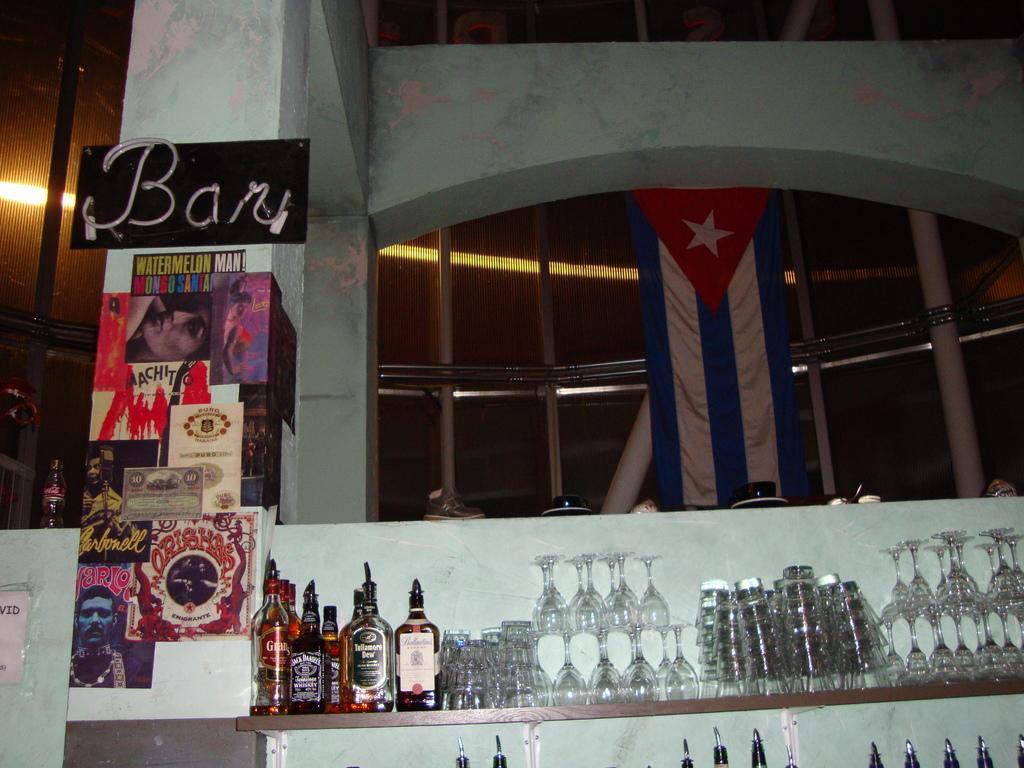Please provide a concise description of this image. In this picture we can see bottles and glasses on the rack. On the left side of the image, there is a pillar with a board and posters attached to it. Behind the bottle, there is a wall. On top of the wall, there are some objects. Behind the wall, there are poles, light, a banner and some objects. In the bottom left corner of the image, it looks like a paper attached to the wall. 